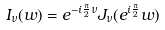<formula> <loc_0><loc_0><loc_500><loc_500>I _ { \nu } ( w ) = e ^ { - i \frac { \pi } { 2 } \nu } J _ { \nu } ( e ^ { i \frac { \pi } { 2 } } w )</formula> 